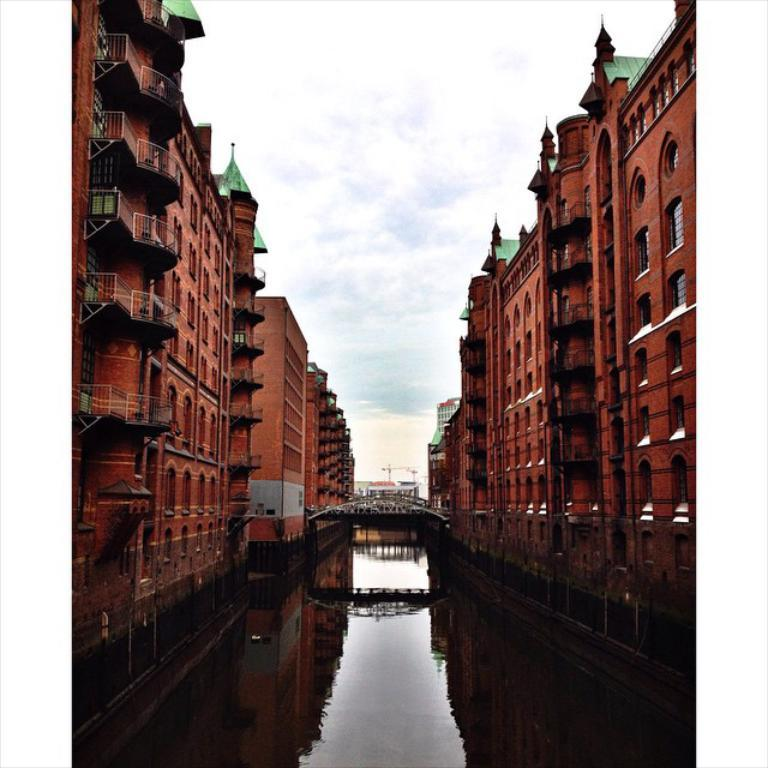What is the main structure in the center of the image? There is a bridge in the center of the image. What can be seen flowing beneath the bridge? There is water visible in the image. What type of structures are present on both sides of the image? There are buildings on both sides of the image. What is visible at the top of the image? The sky is visible at the top of the image. What can be observed in the sky? Clouds are present in the sky. What type of sticks are being used to perform an action in the image? There are no sticks or actions being performed in the image; it features a bridge, water, buildings, and a sky with clouds. 